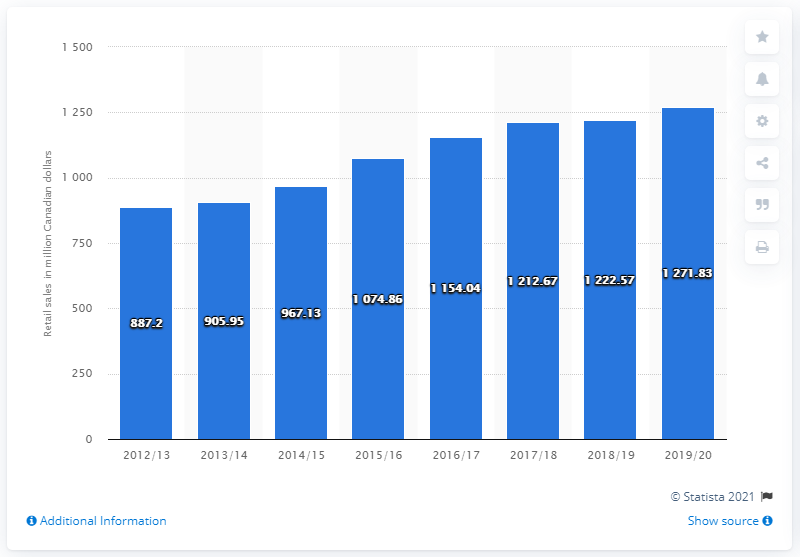Point out several critical features in this image. The retail sales of wine in the Canadian province of British Columbia in the fiscal year ending in March 2020 was 1271.83 million Canadian dollars. 